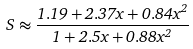<formula> <loc_0><loc_0><loc_500><loc_500>S \approx \frac { 1 . 1 9 + 2 . 3 7 x + 0 . 8 4 x ^ { 2 } } { 1 + 2 . 5 x + 0 . 8 8 x ^ { 2 } }</formula> 